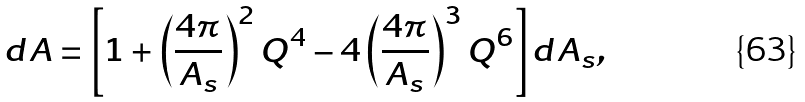Convert formula to latex. <formula><loc_0><loc_0><loc_500><loc_500>d A = \left [ 1 + \left ( \frac { 4 \pi } { A _ { s } } \right ) ^ { 2 } Q ^ { 4 } - 4 \left ( \frac { 4 \pi } { A _ { s } } \right ) ^ { 3 } Q ^ { 6 } \right ] d A _ { s } ,</formula> 